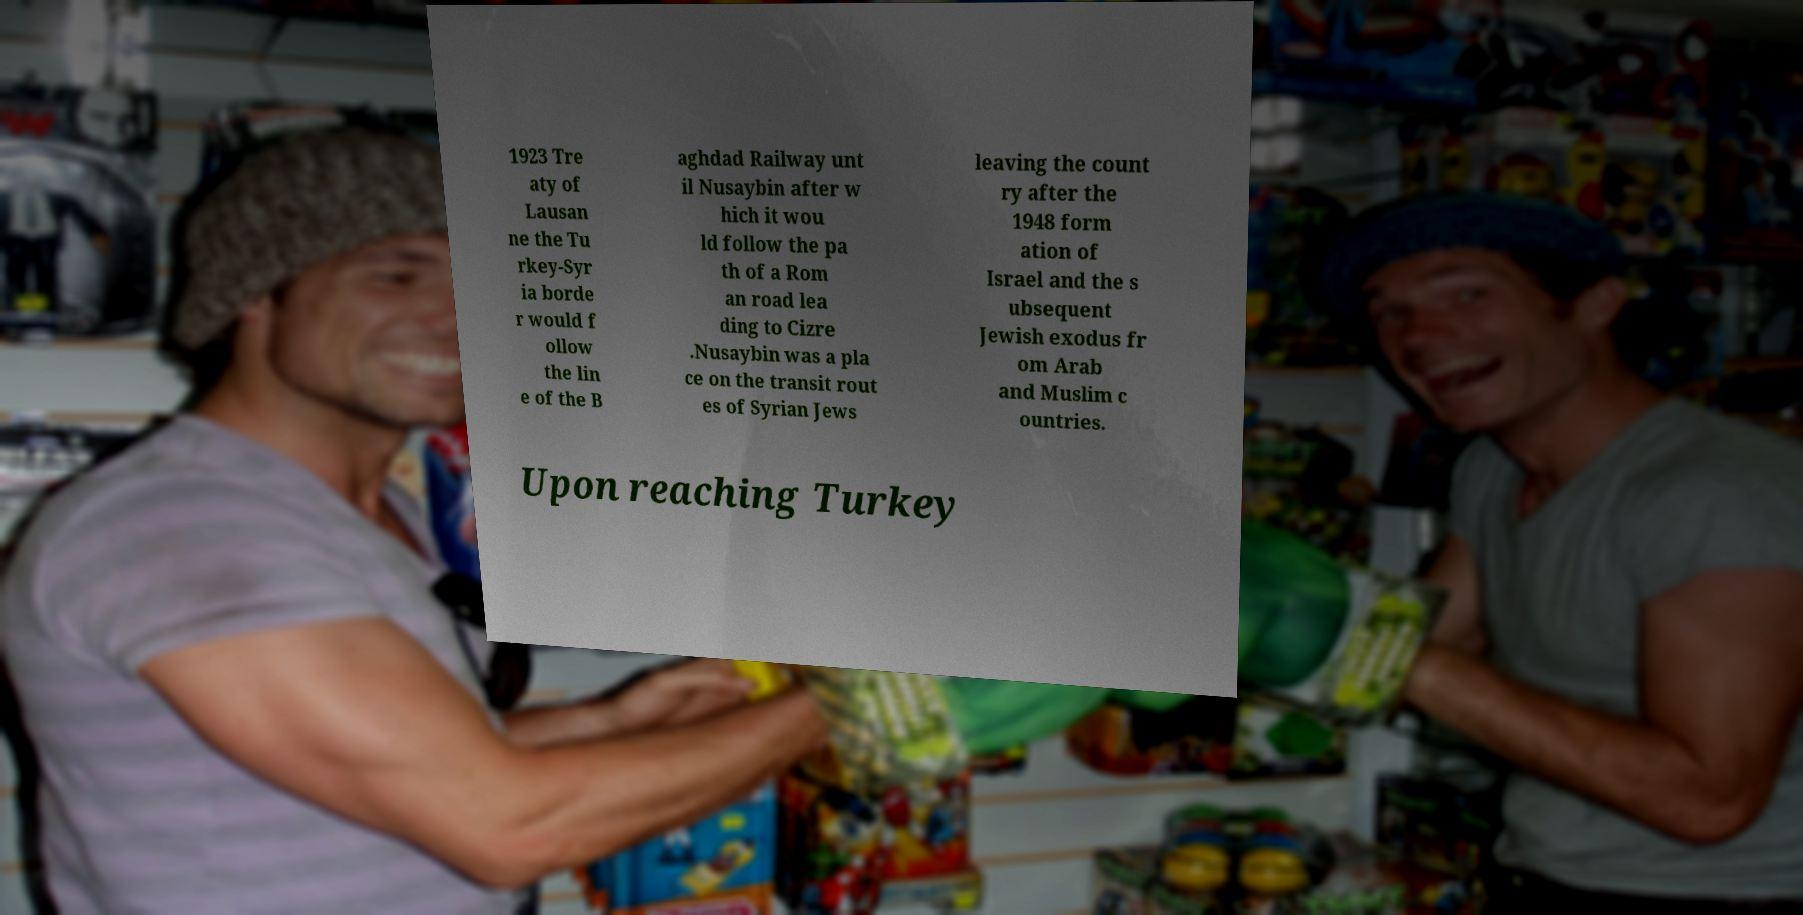For documentation purposes, I need the text within this image transcribed. Could you provide that? 1923 Tre aty of Lausan ne the Tu rkey-Syr ia borde r would f ollow the lin e of the B aghdad Railway unt il Nusaybin after w hich it wou ld follow the pa th of a Rom an road lea ding to Cizre .Nusaybin was a pla ce on the transit rout es of Syrian Jews leaving the count ry after the 1948 form ation of Israel and the s ubsequent Jewish exodus fr om Arab and Muslim c ountries. Upon reaching Turkey 